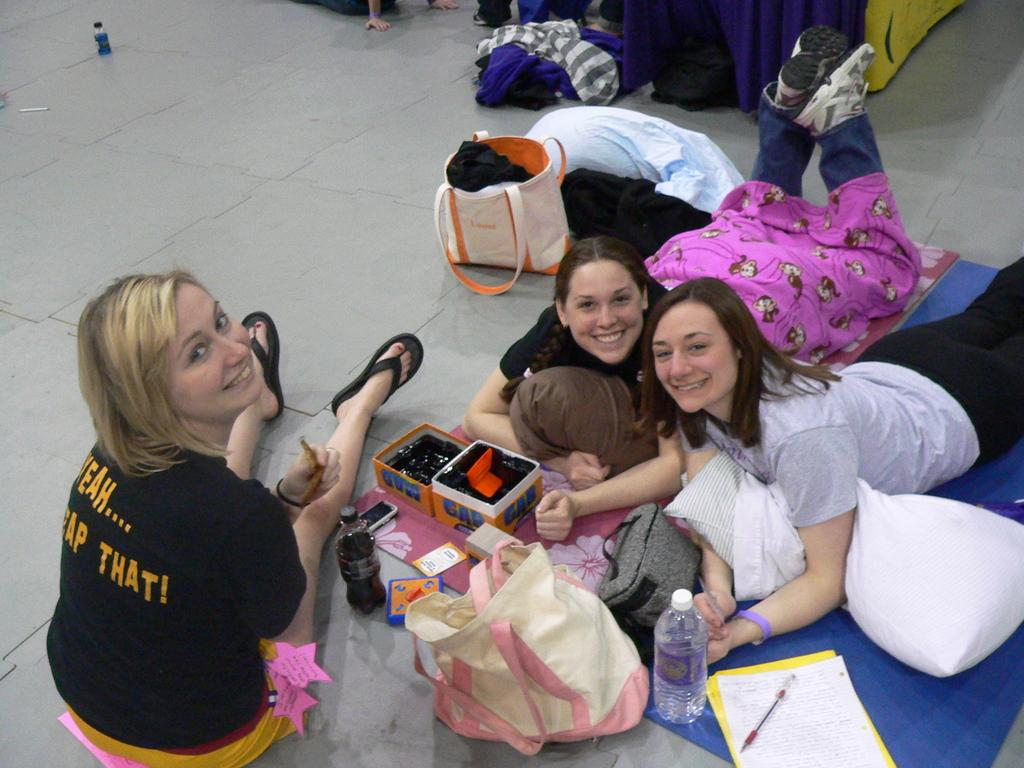<image>
Write a terse but informative summary of the picture. A lady sitting on the floor wearing a shirt with the word "that!" on the back. 